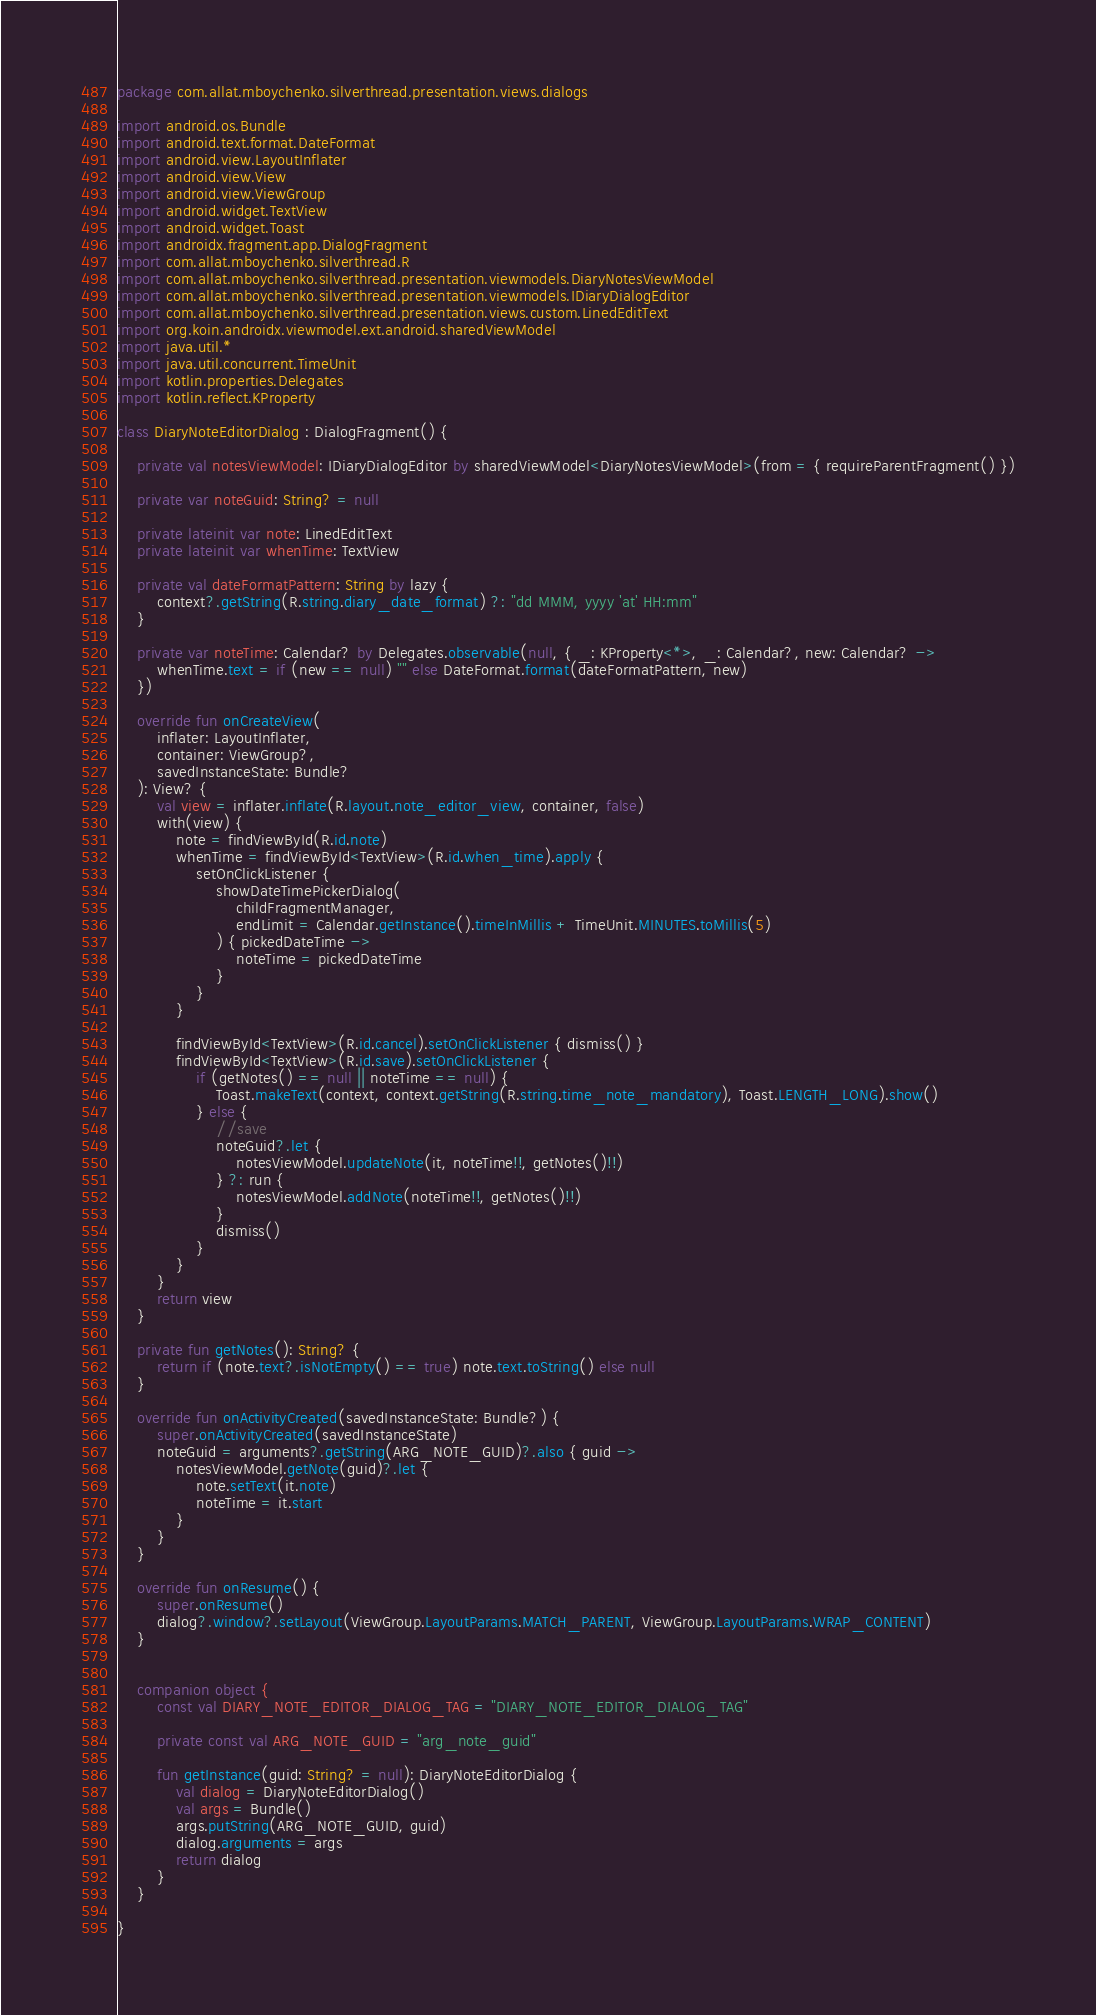<code> <loc_0><loc_0><loc_500><loc_500><_Kotlin_>package com.allat.mboychenko.silverthread.presentation.views.dialogs

import android.os.Bundle
import android.text.format.DateFormat
import android.view.LayoutInflater
import android.view.View
import android.view.ViewGroup
import android.widget.TextView
import android.widget.Toast
import androidx.fragment.app.DialogFragment
import com.allat.mboychenko.silverthread.R
import com.allat.mboychenko.silverthread.presentation.viewmodels.DiaryNotesViewModel
import com.allat.mboychenko.silverthread.presentation.viewmodels.IDiaryDialogEditor
import com.allat.mboychenko.silverthread.presentation.views.custom.LinedEditText
import org.koin.androidx.viewmodel.ext.android.sharedViewModel
import java.util.*
import java.util.concurrent.TimeUnit
import kotlin.properties.Delegates
import kotlin.reflect.KProperty

class DiaryNoteEditorDialog : DialogFragment() {

    private val notesViewModel: IDiaryDialogEditor by sharedViewModel<DiaryNotesViewModel>(from = { requireParentFragment() })

    private var noteGuid: String? = null

    private lateinit var note: LinedEditText
    private lateinit var whenTime: TextView

    private val dateFormatPattern: String by lazy {
        context?.getString(R.string.diary_date_format) ?: "dd MMM, yyyy 'at' HH:mm"
    }

    private var noteTime: Calendar? by Delegates.observable(null, { _: KProperty<*>, _: Calendar?, new: Calendar? ->
        whenTime.text = if (new == null) "" else DateFormat.format(dateFormatPattern, new)
    })

    override fun onCreateView(
        inflater: LayoutInflater,
        container: ViewGroup?,
        savedInstanceState: Bundle?
    ): View? {
        val view = inflater.inflate(R.layout.note_editor_view, container, false)
        with(view) {
            note = findViewById(R.id.note)
            whenTime = findViewById<TextView>(R.id.when_time).apply {
                setOnClickListener {
                    showDateTimePickerDialog(
                        childFragmentManager,
                        endLimit = Calendar.getInstance().timeInMillis + TimeUnit.MINUTES.toMillis(5)
                    ) { pickedDateTime ->
                        noteTime = pickedDateTime
                    }
                }
            }

            findViewById<TextView>(R.id.cancel).setOnClickListener { dismiss() }
            findViewById<TextView>(R.id.save).setOnClickListener {
                if (getNotes() == null || noteTime == null) {
                    Toast.makeText(context, context.getString(R.string.time_note_mandatory), Toast.LENGTH_LONG).show()
                } else {
                    //save
                    noteGuid?.let {
                        notesViewModel.updateNote(it, noteTime!!, getNotes()!!)
                    } ?: run {
                        notesViewModel.addNote(noteTime!!, getNotes()!!)
                    }
                    dismiss()
                }
            }
        }
        return view
    }

    private fun getNotes(): String? {
        return if (note.text?.isNotEmpty() == true) note.text.toString() else null
    }

    override fun onActivityCreated(savedInstanceState: Bundle?) {
        super.onActivityCreated(savedInstanceState)
        noteGuid = arguments?.getString(ARG_NOTE_GUID)?.also { guid ->
            notesViewModel.getNote(guid)?.let {
                note.setText(it.note)
                noteTime = it.start
            }
        }
    }

    override fun onResume() {
        super.onResume()
        dialog?.window?.setLayout(ViewGroup.LayoutParams.MATCH_PARENT, ViewGroup.LayoutParams.WRAP_CONTENT)
    }


    companion object {
        const val DIARY_NOTE_EDITOR_DIALOG_TAG = "DIARY_NOTE_EDITOR_DIALOG_TAG"

        private const val ARG_NOTE_GUID = "arg_note_guid"

        fun getInstance(guid: String? = null): DiaryNoteEditorDialog {
            val dialog = DiaryNoteEditorDialog()
            val args = Bundle()
            args.putString(ARG_NOTE_GUID, guid)
            dialog.arguments = args
            return dialog
        }
    }

}</code> 